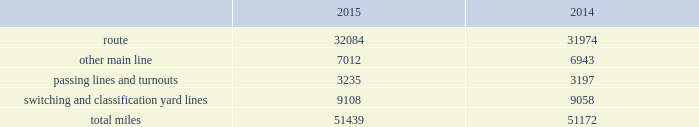Item 1b .
Unresolved staff comments item 2 .
Properties we employ a variety of assets in the management and operation of our rail business .
Our rail network covers 23 states in the western two-thirds of the u.s .
Our rail network includes 32084 route miles .
We own 26064 miles and operate on the remainder pursuant to trackage rights or leases .
The table describes track miles at december 31 , 2015 and 2014. .
Headquarters building we own our headquarters building in omaha , nebraska .
The facility has 1.2 million square feet of space for approximately 4000 employees. .
What percentage of total miles were other main line in 2014? 
Computations: (6943 / 51172)
Answer: 0.13568. 